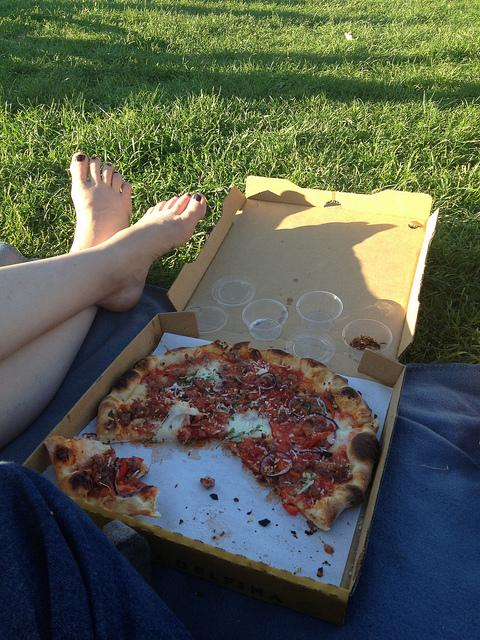What is the proper name for this style of eating?

Choices:
A) picnic
B) brunch
C) party
D) soiree picnic 